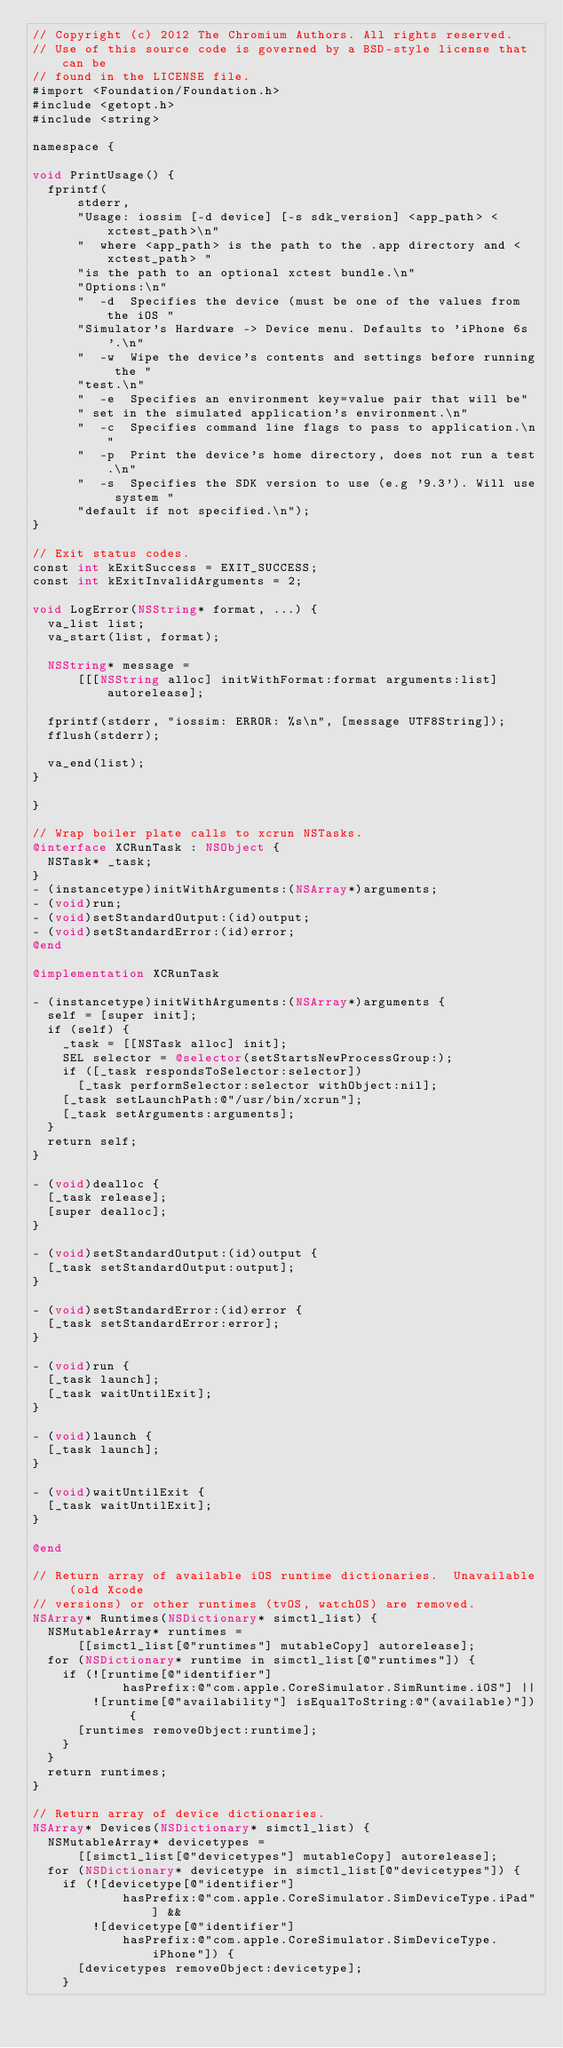<code> <loc_0><loc_0><loc_500><loc_500><_ObjectiveC_>// Copyright (c) 2012 The Chromium Authors. All rights reserved.
// Use of this source code is governed by a BSD-style license that can be
// found in the LICENSE file.
#import <Foundation/Foundation.h>
#include <getopt.h>
#include <string>

namespace {

void PrintUsage() {
  fprintf(
      stderr,
      "Usage: iossim [-d device] [-s sdk_version] <app_path> <xctest_path>\n"
      "  where <app_path> is the path to the .app directory and <xctest_path> "
      "is the path to an optional xctest bundle.\n"
      "Options:\n"
      "  -d  Specifies the device (must be one of the values from the iOS "
      "Simulator's Hardware -> Device menu. Defaults to 'iPhone 6s'.\n"
      "  -w  Wipe the device's contents and settings before running the "
      "test.\n"
      "  -e  Specifies an environment key=value pair that will be"
      " set in the simulated application's environment.\n"
      "  -c  Specifies command line flags to pass to application.\n"
      "  -p  Print the device's home directory, does not run a test.\n"
      "  -s  Specifies the SDK version to use (e.g '9.3'). Will use system "
      "default if not specified.\n");
}

// Exit status codes.
const int kExitSuccess = EXIT_SUCCESS;
const int kExitInvalidArguments = 2;

void LogError(NSString* format, ...) {
  va_list list;
  va_start(list, format);

  NSString* message =
      [[[NSString alloc] initWithFormat:format arguments:list] autorelease];

  fprintf(stderr, "iossim: ERROR: %s\n", [message UTF8String]);
  fflush(stderr);

  va_end(list);
}

}

// Wrap boiler plate calls to xcrun NSTasks.
@interface XCRunTask : NSObject {
  NSTask* _task;
}
- (instancetype)initWithArguments:(NSArray*)arguments;
- (void)run;
- (void)setStandardOutput:(id)output;
- (void)setStandardError:(id)error;
@end

@implementation XCRunTask

- (instancetype)initWithArguments:(NSArray*)arguments {
  self = [super init];
  if (self) {
    _task = [[NSTask alloc] init];
    SEL selector = @selector(setStartsNewProcessGroup:);
    if ([_task respondsToSelector:selector])
      [_task performSelector:selector withObject:nil];
    [_task setLaunchPath:@"/usr/bin/xcrun"];
    [_task setArguments:arguments];
  }
  return self;
}

- (void)dealloc {
  [_task release];
  [super dealloc];
}

- (void)setStandardOutput:(id)output {
  [_task setStandardOutput:output];
}

- (void)setStandardError:(id)error {
  [_task setStandardError:error];
}

- (void)run {
  [_task launch];
  [_task waitUntilExit];
}

- (void)launch {
  [_task launch];
}

- (void)waitUntilExit {
  [_task waitUntilExit];
}

@end

// Return array of available iOS runtime dictionaries.  Unavailable (old Xcode
// versions) or other runtimes (tvOS, watchOS) are removed.
NSArray* Runtimes(NSDictionary* simctl_list) {
  NSMutableArray* runtimes =
      [[simctl_list[@"runtimes"] mutableCopy] autorelease];
  for (NSDictionary* runtime in simctl_list[@"runtimes"]) {
    if (![runtime[@"identifier"]
            hasPrefix:@"com.apple.CoreSimulator.SimRuntime.iOS"] ||
        ![runtime[@"availability"] isEqualToString:@"(available)"]) {
      [runtimes removeObject:runtime];
    }
  }
  return runtimes;
}

// Return array of device dictionaries.
NSArray* Devices(NSDictionary* simctl_list) {
  NSMutableArray* devicetypes =
      [[simctl_list[@"devicetypes"] mutableCopy] autorelease];
  for (NSDictionary* devicetype in simctl_list[@"devicetypes"]) {
    if (![devicetype[@"identifier"]
            hasPrefix:@"com.apple.CoreSimulator.SimDeviceType.iPad"] &&
        ![devicetype[@"identifier"]
            hasPrefix:@"com.apple.CoreSimulator.SimDeviceType.iPhone"]) {
      [devicetypes removeObject:devicetype];
    }</code> 